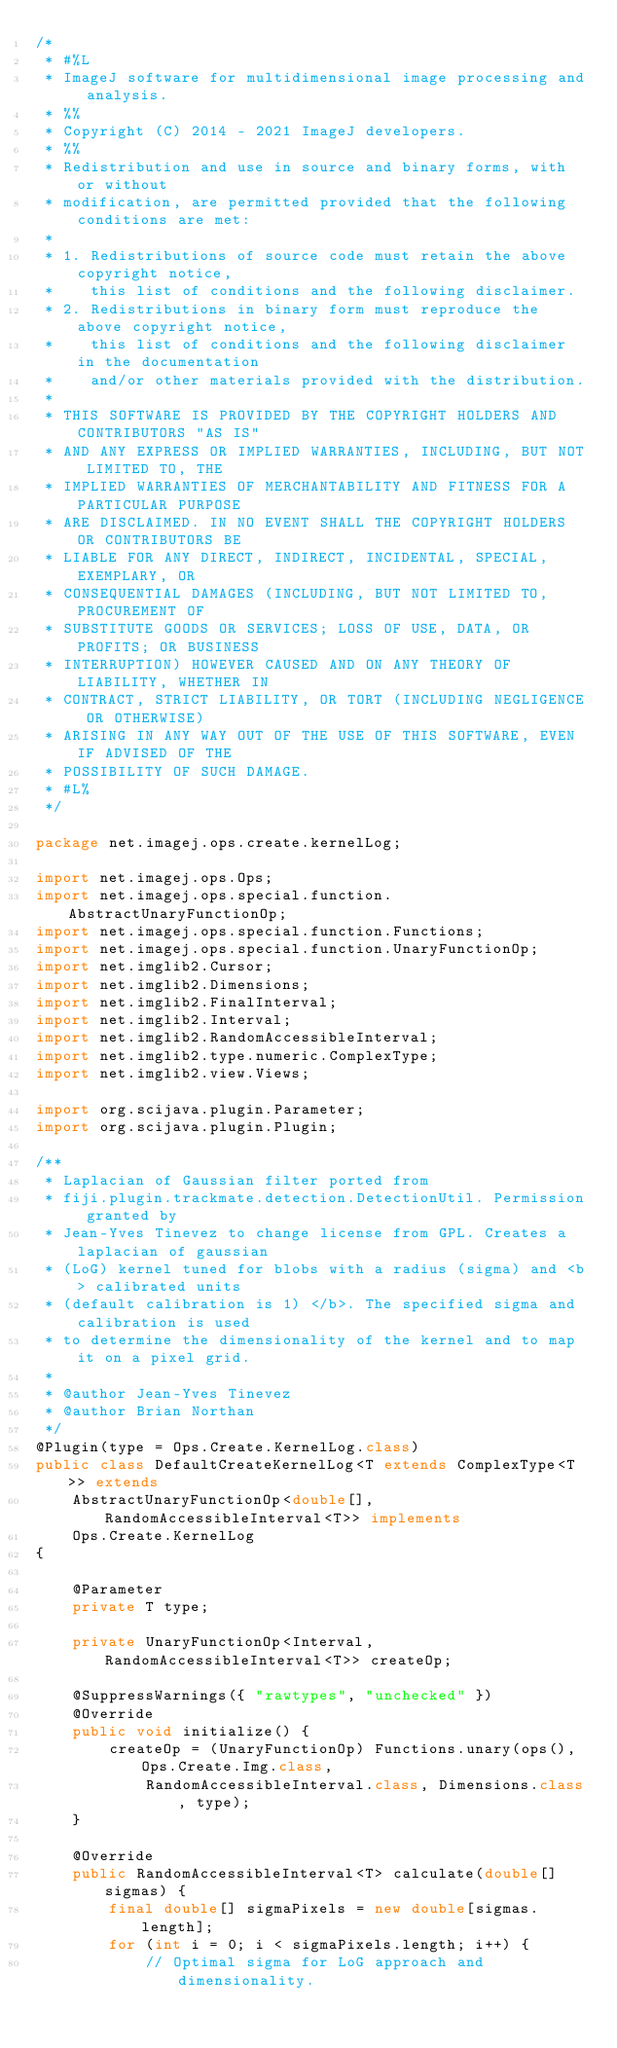<code> <loc_0><loc_0><loc_500><loc_500><_Java_>/*
 * #%L
 * ImageJ software for multidimensional image processing and analysis.
 * %%
 * Copyright (C) 2014 - 2021 ImageJ developers.
 * %%
 * Redistribution and use in source and binary forms, with or without
 * modification, are permitted provided that the following conditions are met:
 * 
 * 1. Redistributions of source code must retain the above copyright notice,
 *    this list of conditions and the following disclaimer.
 * 2. Redistributions in binary form must reproduce the above copyright notice,
 *    this list of conditions and the following disclaimer in the documentation
 *    and/or other materials provided with the distribution.
 * 
 * THIS SOFTWARE IS PROVIDED BY THE COPYRIGHT HOLDERS AND CONTRIBUTORS "AS IS"
 * AND ANY EXPRESS OR IMPLIED WARRANTIES, INCLUDING, BUT NOT LIMITED TO, THE
 * IMPLIED WARRANTIES OF MERCHANTABILITY AND FITNESS FOR A PARTICULAR PURPOSE
 * ARE DISCLAIMED. IN NO EVENT SHALL THE COPYRIGHT HOLDERS OR CONTRIBUTORS BE
 * LIABLE FOR ANY DIRECT, INDIRECT, INCIDENTAL, SPECIAL, EXEMPLARY, OR
 * CONSEQUENTIAL DAMAGES (INCLUDING, BUT NOT LIMITED TO, PROCUREMENT OF
 * SUBSTITUTE GOODS OR SERVICES; LOSS OF USE, DATA, OR PROFITS; OR BUSINESS
 * INTERRUPTION) HOWEVER CAUSED AND ON ANY THEORY OF LIABILITY, WHETHER IN
 * CONTRACT, STRICT LIABILITY, OR TORT (INCLUDING NEGLIGENCE OR OTHERWISE)
 * ARISING IN ANY WAY OUT OF THE USE OF THIS SOFTWARE, EVEN IF ADVISED OF THE
 * POSSIBILITY OF SUCH DAMAGE.
 * #L%
 */

package net.imagej.ops.create.kernelLog;

import net.imagej.ops.Ops;
import net.imagej.ops.special.function.AbstractUnaryFunctionOp;
import net.imagej.ops.special.function.Functions;
import net.imagej.ops.special.function.UnaryFunctionOp;
import net.imglib2.Cursor;
import net.imglib2.Dimensions;
import net.imglib2.FinalInterval;
import net.imglib2.Interval;
import net.imglib2.RandomAccessibleInterval;
import net.imglib2.type.numeric.ComplexType;
import net.imglib2.view.Views;

import org.scijava.plugin.Parameter;
import org.scijava.plugin.Plugin;

/**
 * Laplacian of Gaussian filter ported from
 * fiji.plugin.trackmate.detection.DetectionUtil. Permission granted by
 * Jean-Yves Tinevez to change license from GPL. Creates a laplacian of gaussian
 * (LoG) kernel tuned for blobs with a radius (sigma) and <b> calibrated units
 * (default calibration is 1) </b>. The specified sigma and calibration is used
 * to determine the dimensionality of the kernel and to map it on a pixel grid.
 *
 * @author Jean-Yves Tinevez
 * @author Brian Northan
 */
@Plugin(type = Ops.Create.KernelLog.class)
public class DefaultCreateKernelLog<T extends ComplexType<T>> extends
	AbstractUnaryFunctionOp<double[], RandomAccessibleInterval<T>> implements
	Ops.Create.KernelLog
{

	@Parameter
	private T type;

	private UnaryFunctionOp<Interval, RandomAccessibleInterval<T>> createOp;

	@SuppressWarnings({ "rawtypes", "unchecked" })
	@Override
	public void initialize() {
		createOp = (UnaryFunctionOp) Functions.unary(ops(), Ops.Create.Img.class,
			RandomAccessibleInterval.class, Dimensions.class, type);
	}

	@Override
	public RandomAccessibleInterval<T> calculate(double[] sigmas) {
		final double[] sigmaPixels = new double[sigmas.length];
		for (int i = 0; i < sigmaPixels.length; i++) {
			// Optimal sigma for LoG approach and dimensionality.</code> 